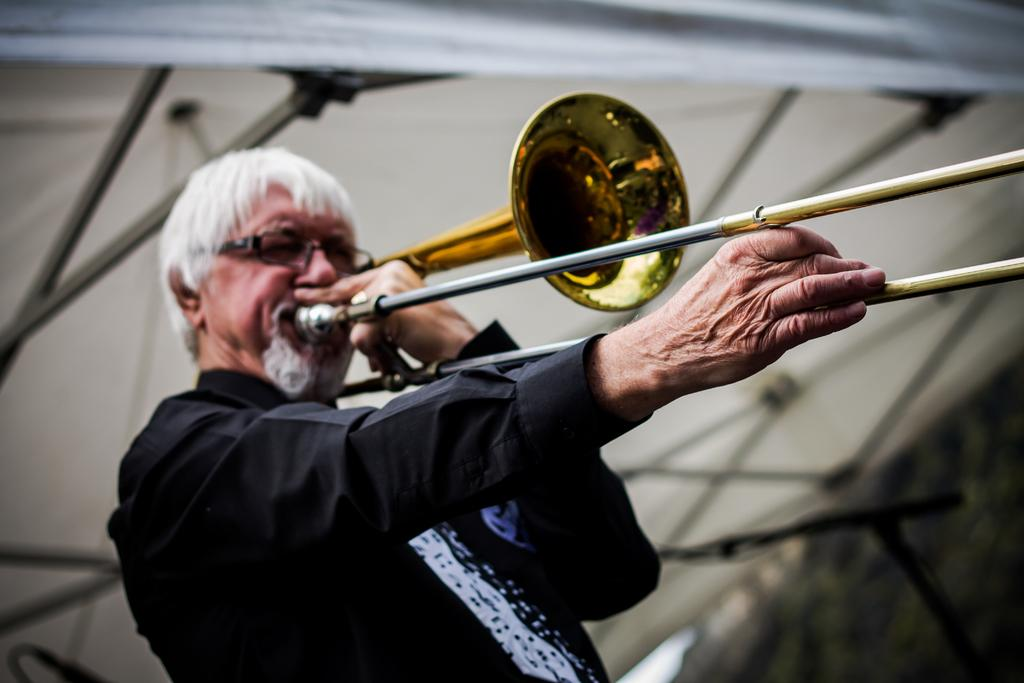What is the main subject of the image? The main subject of the image is a man. What is the man doing in the image? The man is standing and playing a trombone. Can you describe the man's appearance? The man is wearing spectacles. What else can be seen in the image? There is a tent in the image. What type of scissors can be seen in the image? There are no scissors present in the image. What is the texture of the man's shirt in the image? The provided facts do not mention the texture of the man's shirt, so we cannot determine its texture from the image. 